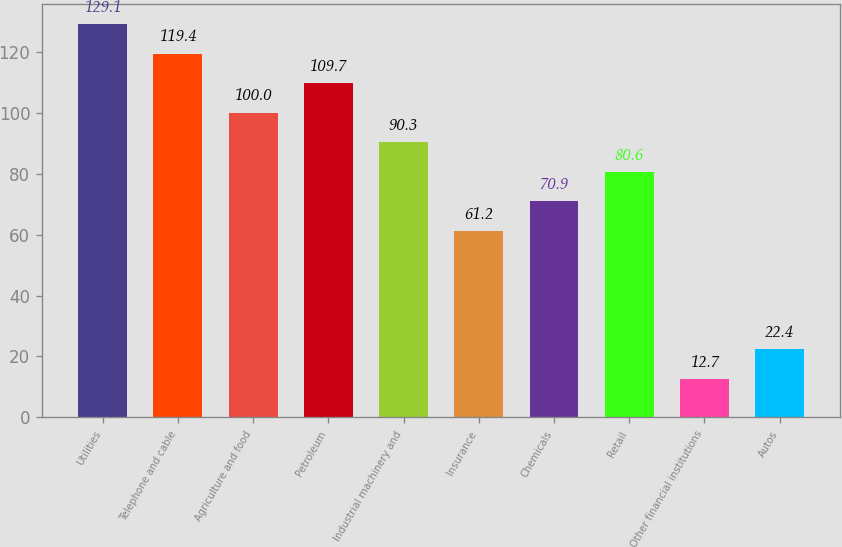<chart> <loc_0><loc_0><loc_500><loc_500><bar_chart><fcel>Utilities<fcel>Telephone and cable<fcel>Agriculture and food<fcel>Petroleum<fcel>Industrial machinery and<fcel>Insurance<fcel>Chemicals<fcel>Retail<fcel>Other financial institutions<fcel>Autos<nl><fcel>129.1<fcel>119.4<fcel>100<fcel>109.7<fcel>90.3<fcel>61.2<fcel>70.9<fcel>80.6<fcel>12.7<fcel>22.4<nl></chart> 